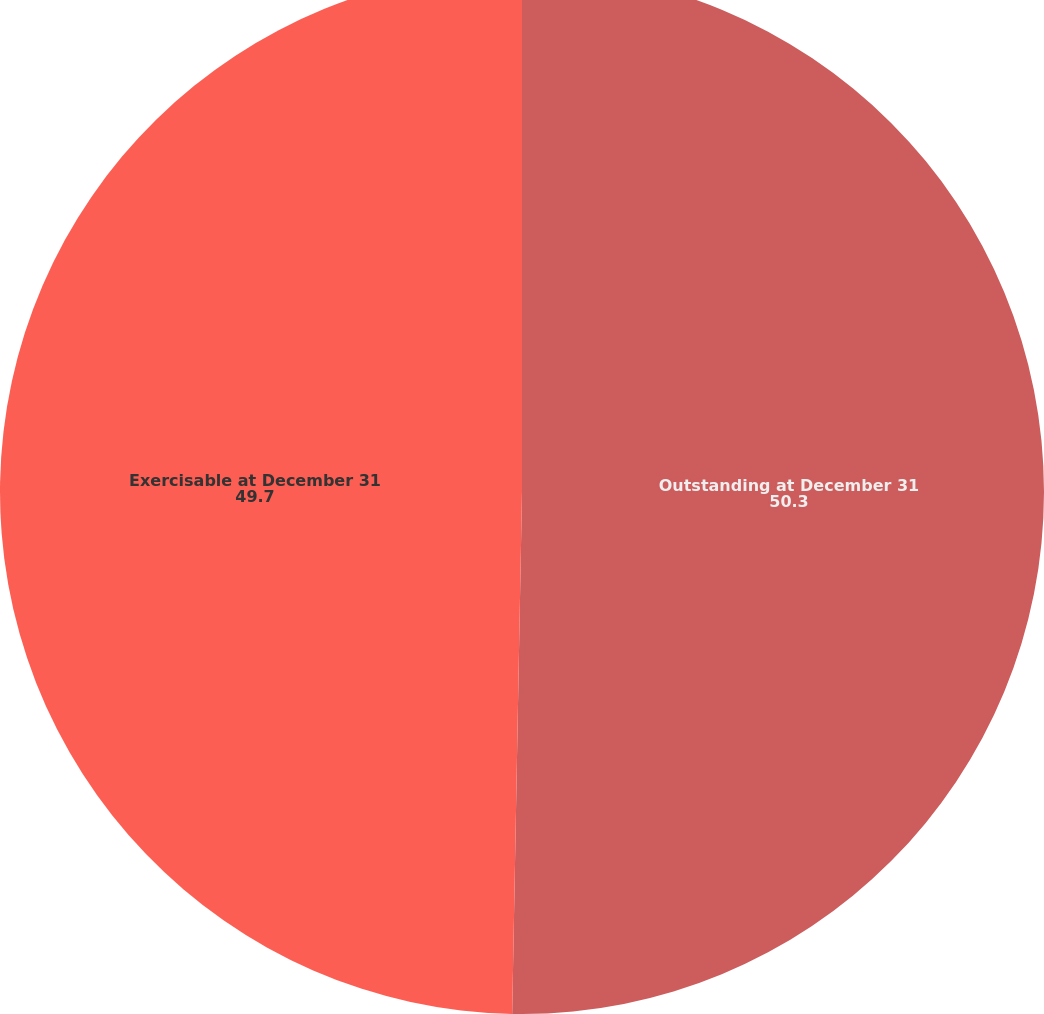Convert chart to OTSL. <chart><loc_0><loc_0><loc_500><loc_500><pie_chart><fcel>Outstanding at December 31<fcel>Exercisable at December 31<nl><fcel>50.3%<fcel>49.7%<nl></chart> 